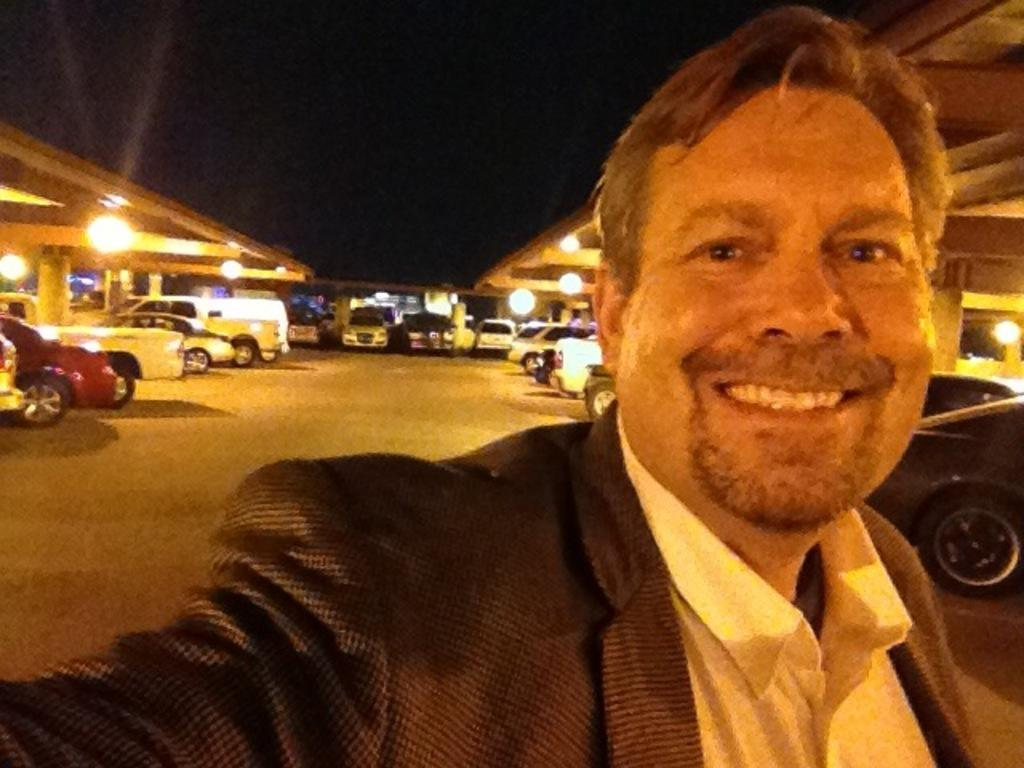What is the expression of the person in the image? There is a person with a smile in the image. What can be seen in the parking space in the image? There are vehicles in a parking space in the image. What is visible in the image that provides illumination? There are lights visible in the image. What does the person in the image regret in the image? There is no indication of regret in the image, as the person is smiling. What type of voice can be heard coming from the person in the image? There is no audio in the image, so it is not possible to determine the person's voice. 